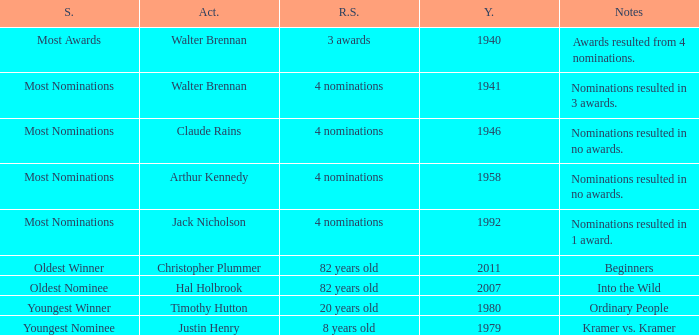What record was set by walter brennan before 1941? 3 awards. 